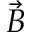Convert formula to latex. <formula><loc_0><loc_0><loc_500><loc_500>\ V e c { B }</formula> 